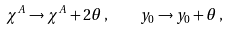Convert formula to latex. <formula><loc_0><loc_0><loc_500><loc_500>\chi ^ { A } \rightarrow \chi ^ { A } + 2 \theta \, , \quad y _ { 0 } \rightarrow y _ { 0 } + \theta \, ,</formula> 